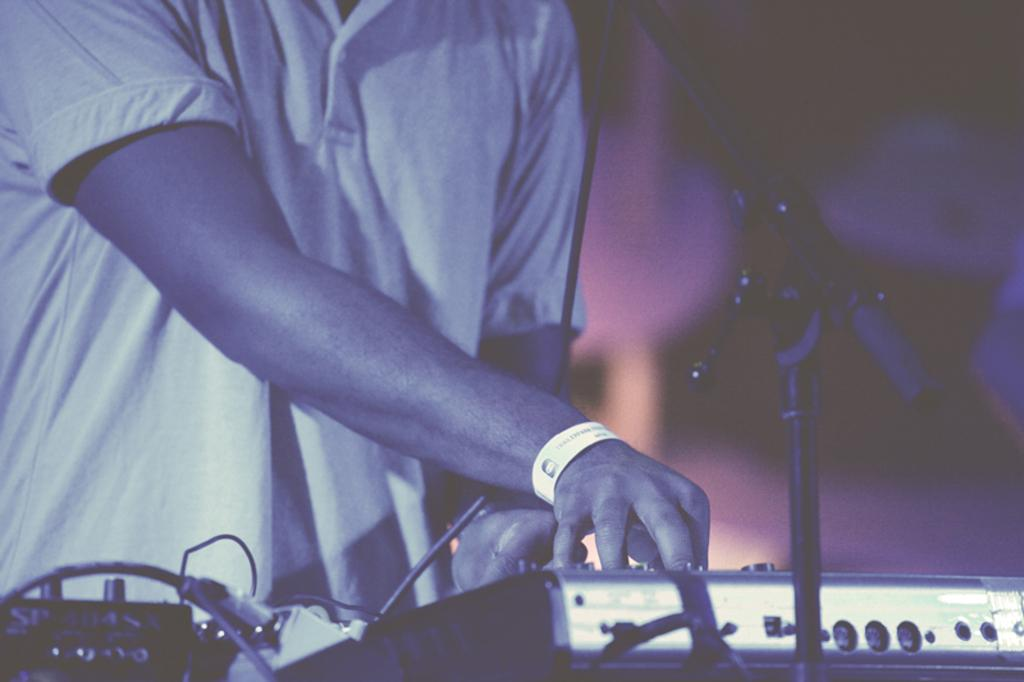What is the person in the image doing? The person is playing a musical instrument. What object is in the foreground of the image? There is a microphone on a stand in the foreground. What can be seen on the table in the image? There are devices on a table in the image. Can you see a badge on the person's shirt in the image? There is no mention of a badge in the provided facts, so it cannot be determined if one is present in the image. 